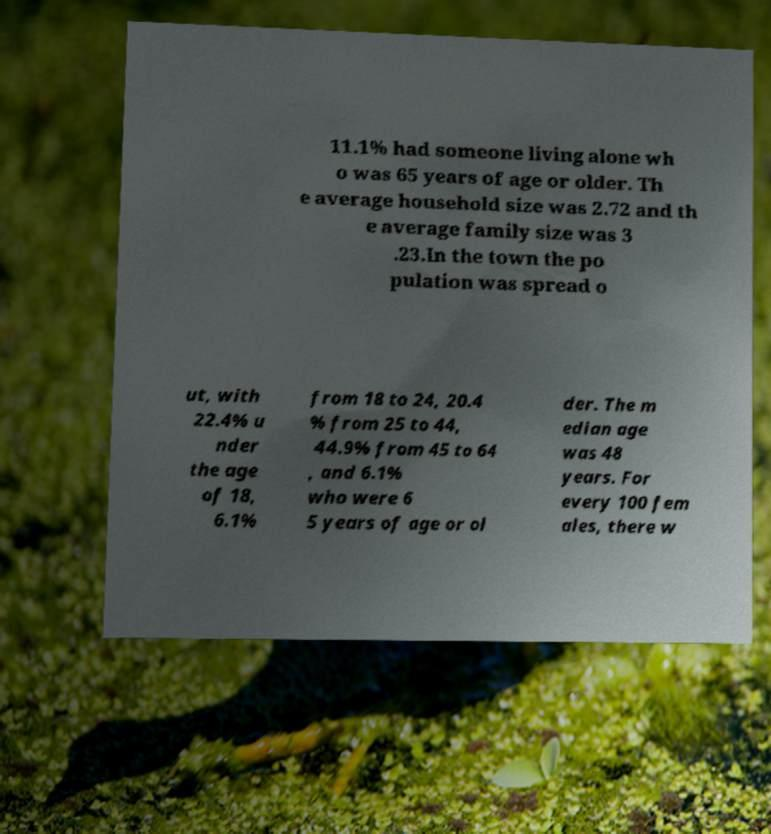Can you accurately transcribe the text from the provided image for me? 11.1% had someone living alone wh o was 65 years of age or older. Th e average household size was 2.72 and th e average family size was 3 .23.In the town the po pulation was spread o ut, with 22.4% u nder the age of 18, 6.1% from 18 to 24, 20.4 % from 25 to 44, 44.9% from 45 to 64 , and 6.1% who were 6 5 years of age or ol der. The m edian age was 48 years. For every 100 fem ales, there w 